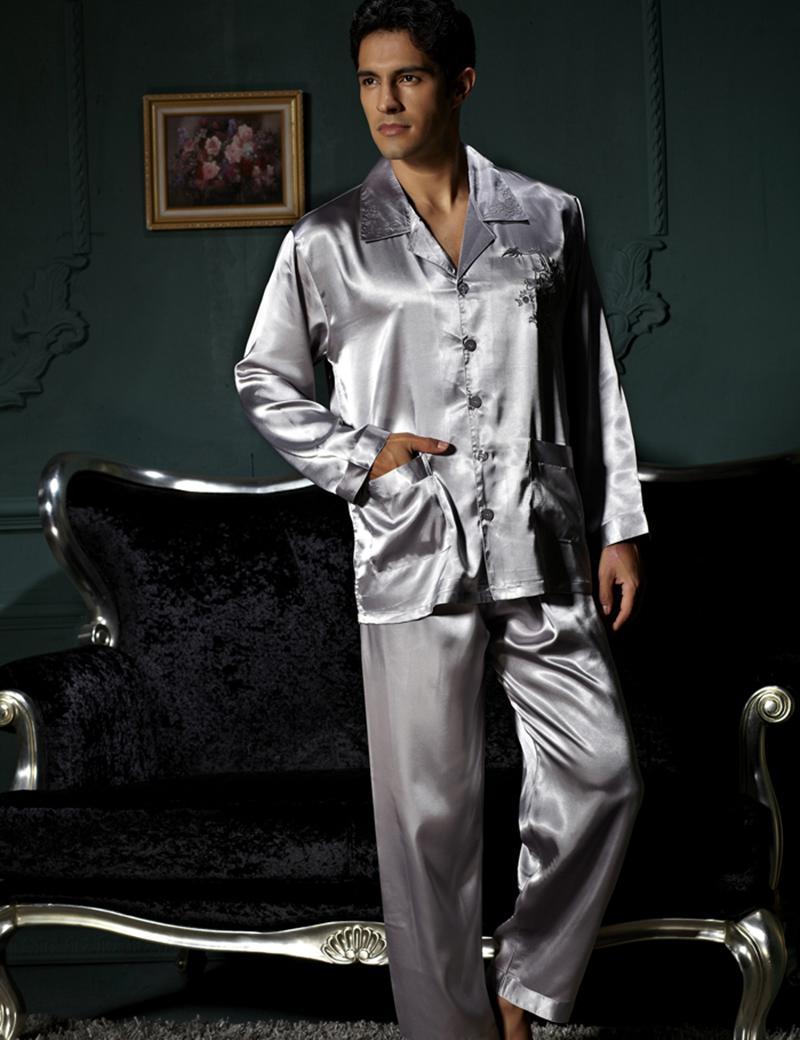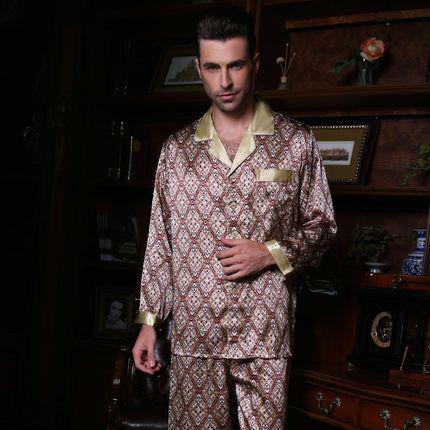The first image is the image on the left, the second image is the image on the right. Given the left and right images, does the statement "A man's silky diamond design pajama shirt has contrasting color at the collar, sleeve cuffs and pocket edge." hold true? Answer yes or no. Yes. 